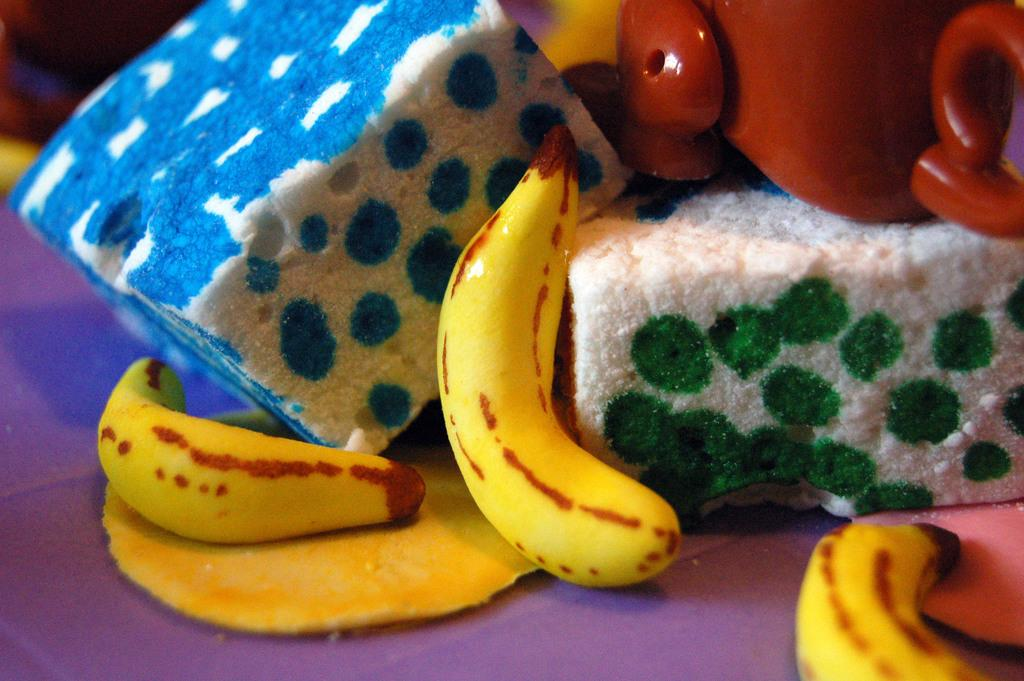What type of objects can be seen in the image? The image contains toys and bananas. Can you describe the location of the bananas in the image? The bananas are in the front of the image. What material are the objects on the desk made of? The objects on the desk are made up of thermocol. What type of pig can be seen playing with a kitten in the image? There is no pig or kitten present in the image; it contains toys and bananas. How many baseballs are visible in the image? There are no baseballs visible in the image. 